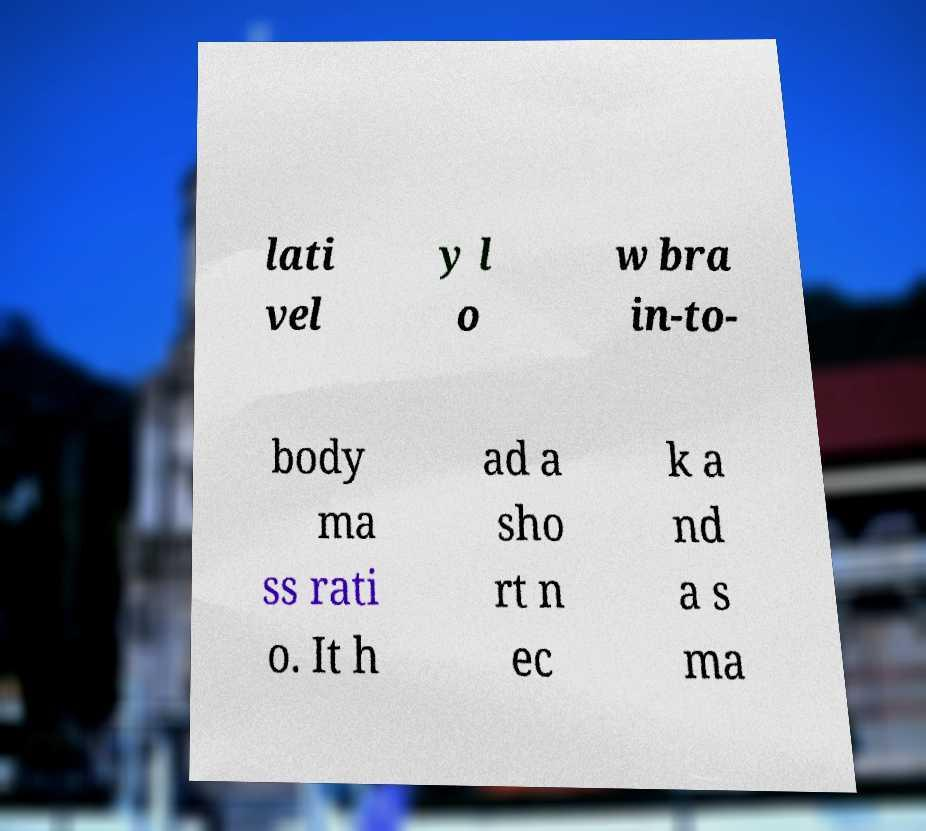What messages or text are displayed in this image? I need them in a readable, typed format. lati vel y l o w bra in-to- body ma ss rati o. It h ad a sho rt n ec k a nd a s ma 